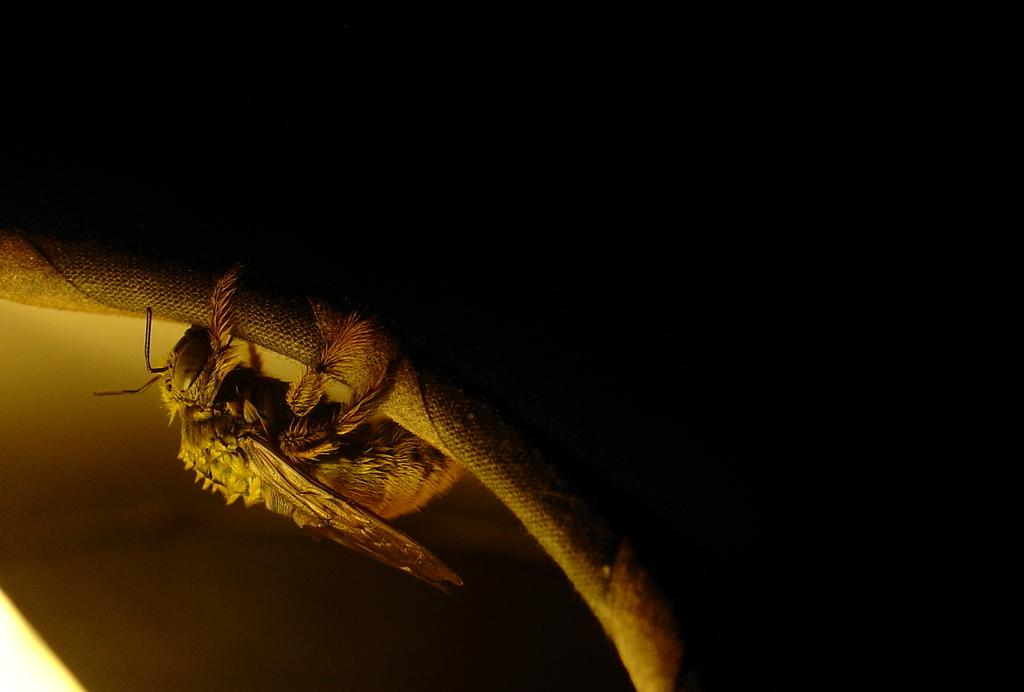What type of creature can be seen in the image? There is an insect in the image. What is the insect doing in the image? The insect is laying on a surface. What type of journey is the insect taking in the image? There is no indication of a journey in the image; the insect is simply laying on a surface. 